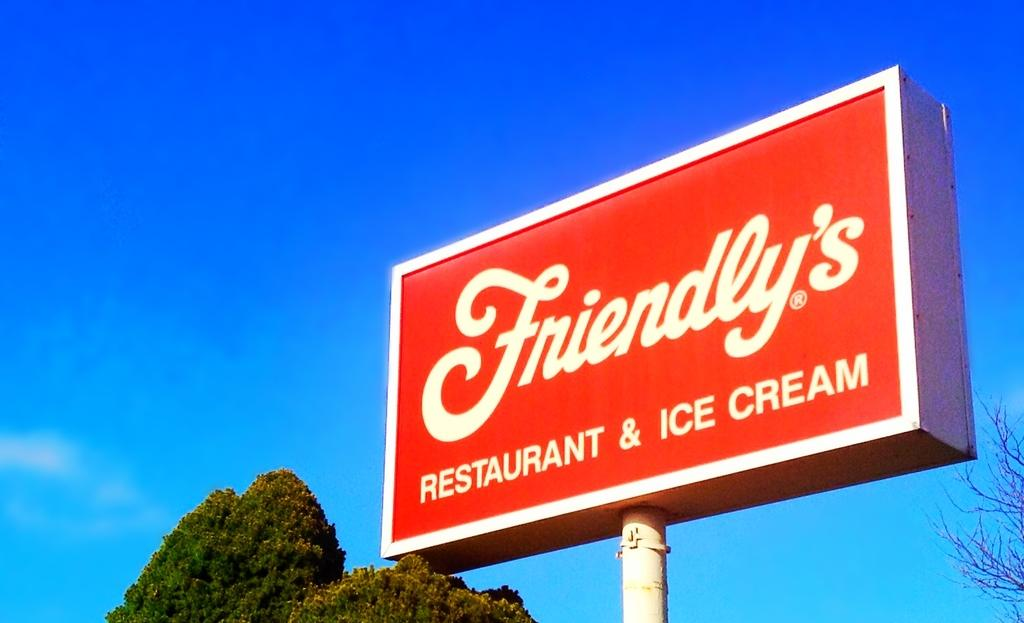<image>
Render a clear and concise summary of the photo. A red sign bares the logo for Friendly's Restaurant and Ice Cream 